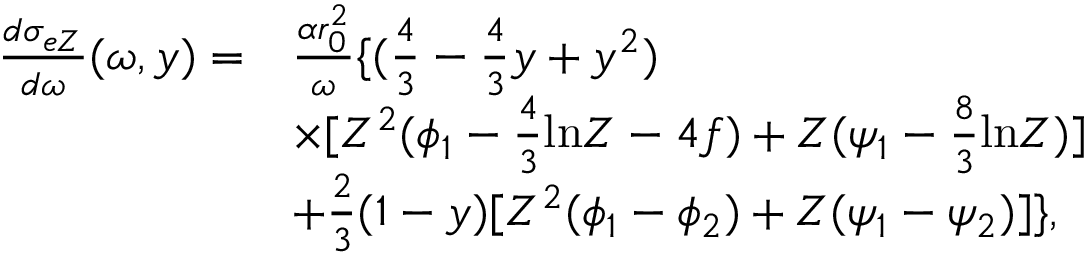Convert formula to latex. <formula><loc_0><loc_0><loc_500><loc_500>\begin{array} { r l } { \frac { d \sigma _ { e Z } } { d \omega } ( \omega , y ) = } & { \frac { \alpha r _ { 0 } ^ { 2 } } { \omega } \{ ( \frac { 4 } { 3 } - \frac { 4 } { 3 } y + y ^ { 2 } ) } \\ & { \times [ Z ^ { 2 } ( \phi _ { 1 } - \frac { 4 } { 3 } \ln Z - 4 f ) + Z ( \psi _ { 1 } - \frac { 8 } { 3 } \ln Z ) ] } \\ & { + \frac { 2 } { 3 } ( 1 - y ) [ Z ^ { 2 } ( \phi _ { 1 } - \phi _ { 2 } ) + Z ( \psi _ { 1 } - \psi _ { 2 } ) ] \} , } \end{array}</formula> 